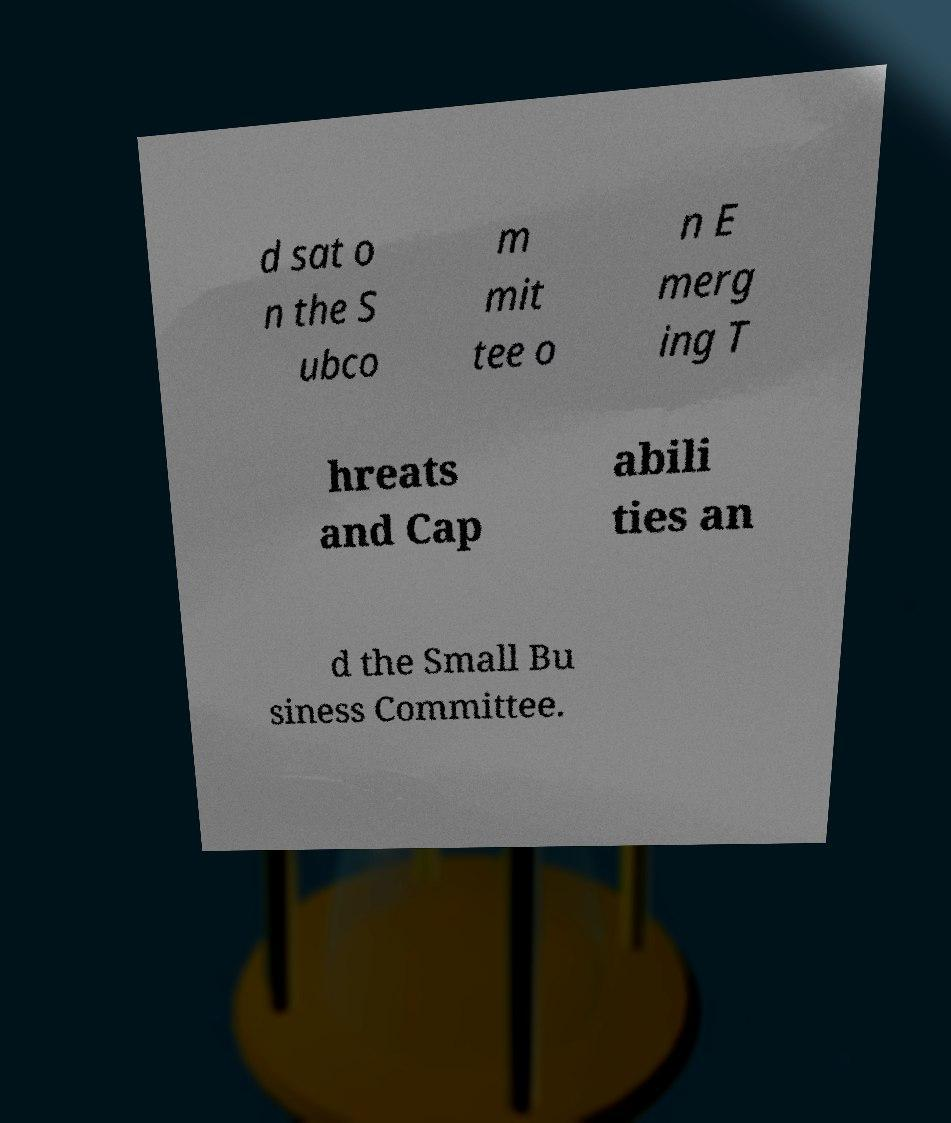Please read and relay the text visible in this image. What does it say? d sat o n the S ubco m mit tee o n E merg ing T hreats and Cap abili ties an d the Small Bu siness Committee. 